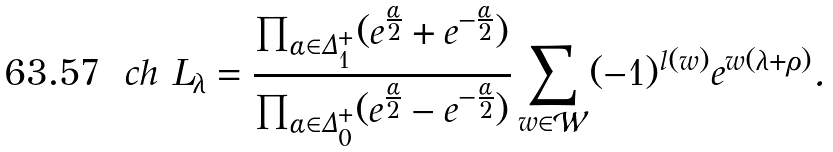<formula> <loc_0><loc_0><loc_500><loc_500>c h \ L _ { \lambda } = \frac { \prod _ { \alpha \in \Delta _ { 1 } ^ { + } } ( e ^ { \frac { \alpha } { 2 } } + e ^ { - \frac { \alpha } { 2 } } ) } { \prod _ { \alpha \in \Delta _ { 0 } ^ { + } } ( e ^ { \frac { \alpha } { 2 } } - e ^ { - \frac { \alpha } { 2 } } ) } \sum _ { w \in \mathcal { W } } ( - 1 ) ^ { l ( w ) } e ^ { w ( \lambda + \rho ) } .</formula> 